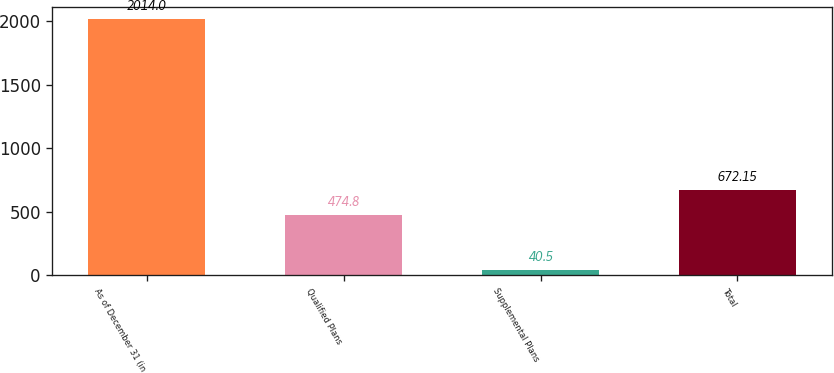Convert chart. <chart><loc_0><loc_0><loc_500><loc_500><bar_chart><fcel>As of December 31 (in<fcel>Qualified Plans<fcel>Supplemental Plans<fcel>Total<nl><fcel>2014<fcel>474.8<fcel>40.5<fcel>672.15<nl></chart> 